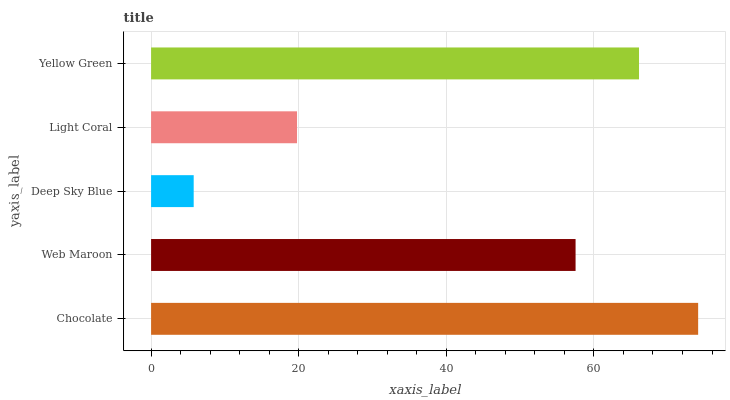Is Deep Sky Blue the minimum?
Answer yes or no. Yes. Is Chocolate the maximum?
Answer yes or no. Yes. Is Web Maroon the minimum?
Answer yes or no. No. Is Web Maroon the maximum?
Answer yes or no. No. Is Chocolate greater than Web Maroon?
Answer yes or no. Yes. Is Web Maroon less than Chocolate?
Answer yes or no. Yes. Is Web Maroon greater than Chocolate?
Answer yes or no. No. Is Chocolate less than Web Maroon?
Answer yes or no. No. Is Web Maroon the high median?
Answer yes or no. Yes. Is Web Maroon the low median?
Answer yes or no. Yes. Is Light Coral the high median?
Answer yes or no. No. Is Yellow Green the low median?
Answer yes or no. No. 